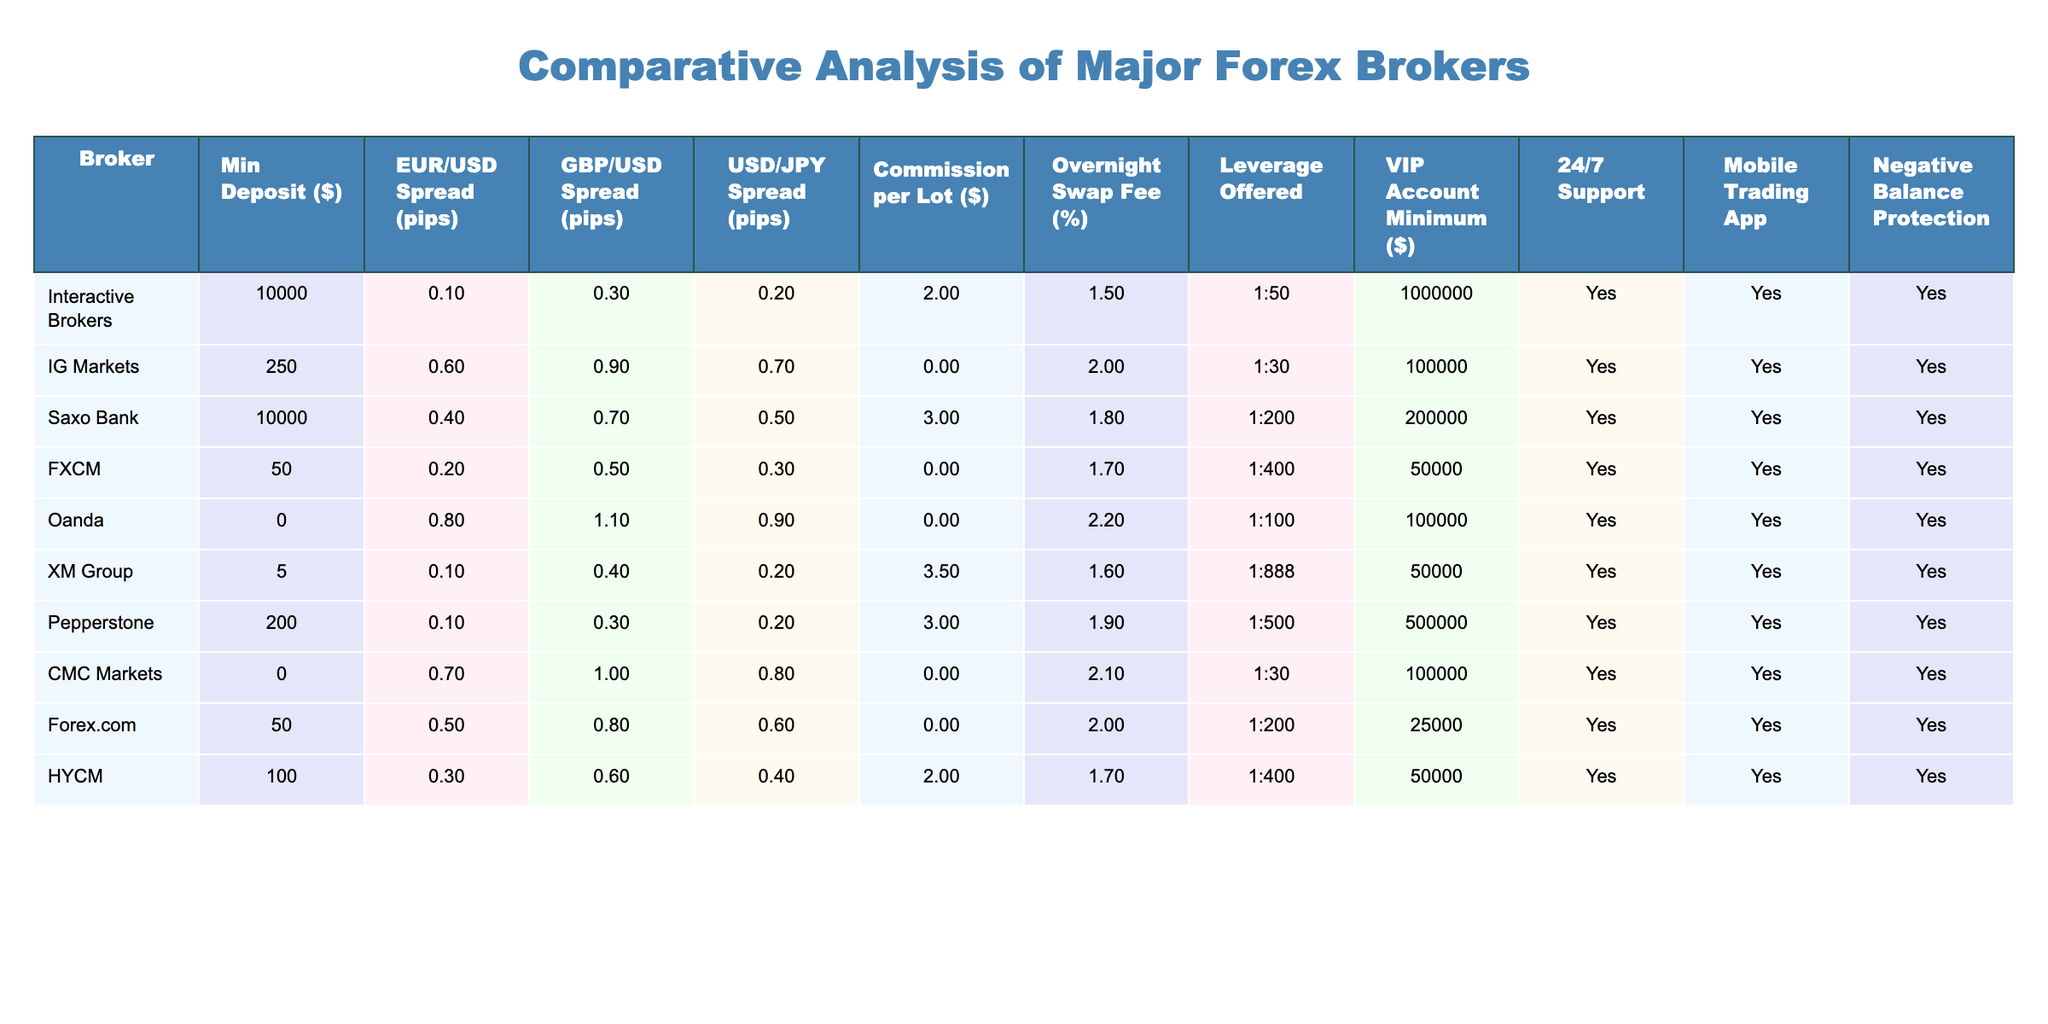What is the minimum deposit required to open an account with IG Markets? From the table, the minimum deposit for IG Markets is listed under the "Min Deposit ($)" column, which shows the value as 250.
Answer: 250 Which broker has the lowest EUR/USD spread? The EUR/USD spread values in the table are compared, and XM Group and Pepperstone both have a spread of 0.1, which is the lowest among all brokers.
Answer: XM Group and Pepperstone What is the commission per lot for forex trading at Saxo Bank? The commission per lot is directly indicated in the table under Saxo Bank, which states that the commission is 3 dollars per lot.
Answer: 3 How many brokers offer negative balance protection? The table lists 'Yes' or 'No' under the "Negative Balance Protection" column for each broker. Counting the 'Yes' responses, we find that 9 brokers provide this feature.
Answer: 9 What is the average spread for USD/JPY across all brokers? The USD/JPY spreads are listed as 0.2, 0.7, 0.5, 0.3, 0.9, 0.2, 0.2, 0.8, 0.6, and 0.4. Summing these values gives 4.8. There are 10 brokers, so the average spread is 4.8 / 10 = 0.48.
Answer: 0.48 Which broker has the highest leverage offered, and what is that value? By reviewing the "Leverage Offered" column, it is clear that XM Group has the highest leverage at 1:888.
Answer: XM Group, 1:888 Is there a broker that requires a minimum deposit of zero dollars? The table shows Oanda with a minimum deposit specified as $0. Thus, the answer is yes, Oanda has no minimum deposit requirement.
Answer: Yes How does the overnight swap fee at FXCM compare to that of Pepperstone? FXCM has an overnight swap fee of 1.7%, while Pepperstone has a fee of 1.9%. Since 1.7% is less than 1.9%, FXCM has a lower fee than Pepperstone.
Answer: FXCM has a lower fee Which broker offers the highest minimum deposit requirement? The minimum deposits are compared, and Interactive Brokers requires the highest deposit of $10,000.
Answer: Interactive Brokers If we consider brokers with a minimum deposit of less than $1000, how many of them offer 24/7 support? By analyzing the table, except for Interactive Brokers and Saxo Bank, all remaining brokers (7) offer 24/7 support.
Answer: 7 